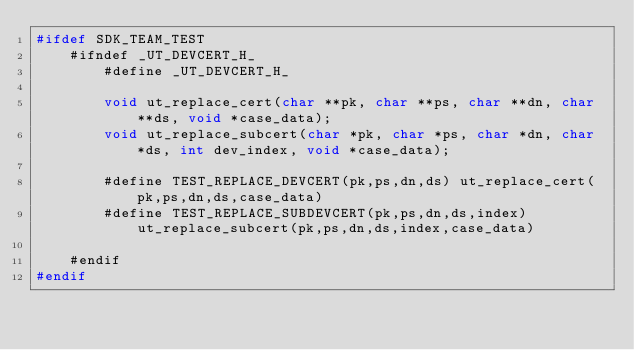Convert code to text. <code><loc_0><loc_0><loc_500><loc_500><_C_>#ifdef SDK_TEAM_TEST
    #ifndef _UT_DEVCERT_H_
        #define _UT_DEVCERT_H_

        void ut_replace_cert(char **pk, char **ps, char **dn, char **ds, void *case_data);
        void ut_replace_subcert(char *pk, char *ps, char *dn, char *ds, int dev_index, void *case_data);

        #define TEST_REPLACE_DEVCERT(pk,ps,dn,ds) ut_replace_cert(pk,ps,dn,ds,case_data)
        #define TEST_REPLACE_SUBDEVCERT(pk,ps,dn,ds,index) ut_replace_subcert(pk,ps,dn,ds,index,case_data)

    #endif
#endif</code> 